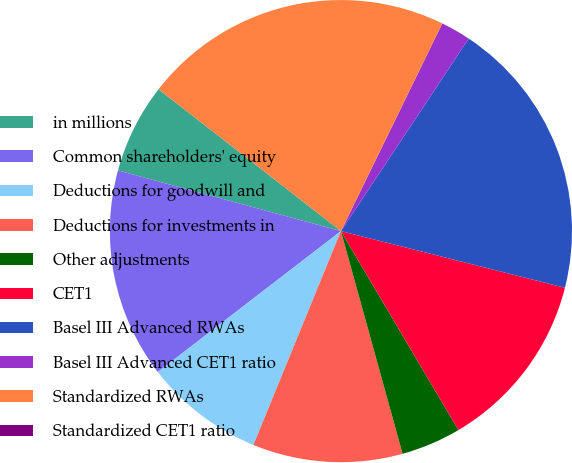<chart> <loc_0><loc_0><loc_500><loc_500><pie_chart><fcel>in millions<fcel>Common shareholders' equity<fcel>Deductions for goodwill and<fcel>Deductions for investments in<fcel>Other adjustments<fcel>CET1<fcel>Basel III Advanced RWAs<fcel>Basel III Advanced CET1 ratio<fcel>Standardized RWAs<fcel>Standardized CET1 ratio<nl><fcel>6.29%<fcel>14.67%<fcel>8.38%<fcel>10.48%<fcel>4.19%<fcel>12.57%<fcel>19.62%<fcel>2.1%<fcel>21.71%<fcel>0.0%<nl></chart> 